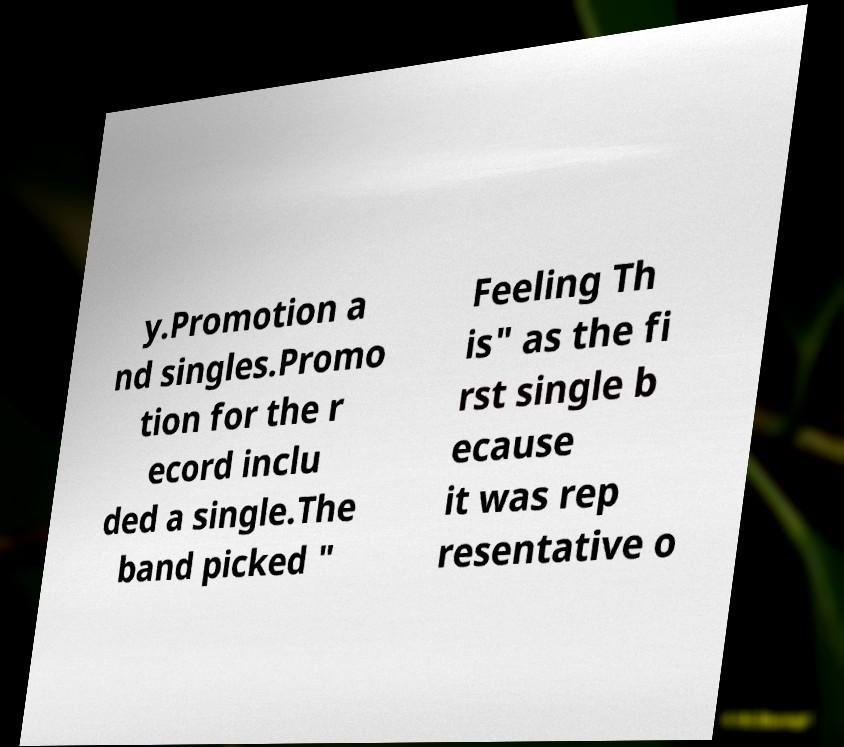Please identify and transcribe the text found in this image. y.Promotion a nd singles.Promo tion for the r ecord inclu ded a single.The band picked " Feeling Th is" as the fi rst single b ecause it was rep resentative o 